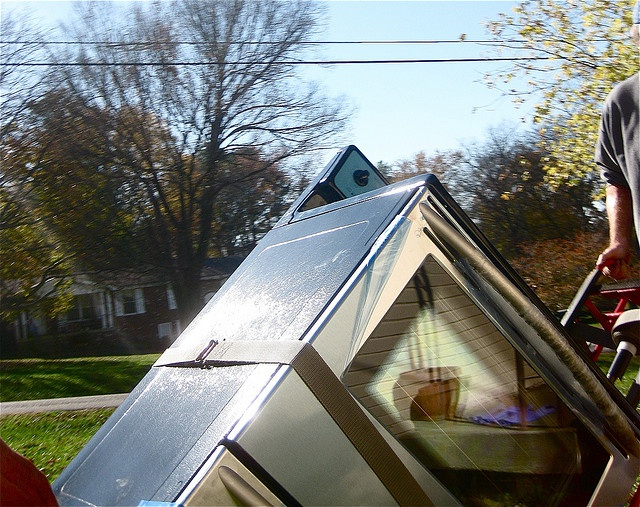Describe the objects in this image and their specific colors. I can see oven in white, black, gray, and darkgray tones and people in white, black, darkgray, maroon, and gray tones in this image. 